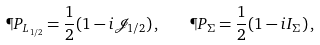Convert formula to latex. <formula><loc_0><loc_0><loc_500><loc_500>\P P _ { L _ { 1 / 2 } } = \frac { 1 } { 2 } ( 1 - i \mathcal { J } _ { 1 / 2 } ) \, , \quad \P P _ { \Sigma } = \frac { 1 } { 2 } ( 1 - i I _ { \Sigma } ) \, ,</formula> 